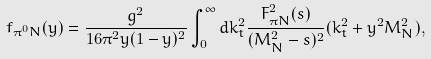<formula> <loc_0><loc_0><loc_500><loc_500>f _ { \pi ^ { 0 } N } ( y ) = \frac { g ^ { 2 } } { 1 6 \pi ^ { 2 } y ( 1 - y ) ^ { 2 } } \int _ { 0 } ^ { \infty } d k _ { t } ^ { 2 } \frac { F _ { \pi N } ^ { 2 } ( s ) } { ( M _ { N } ^ { 2 } - s ) ^ { 2 } } ( k _ { t } ^ { 2 } + y ^ { 2 } M _ { N } ^ { 2 } ) ,</formula> 